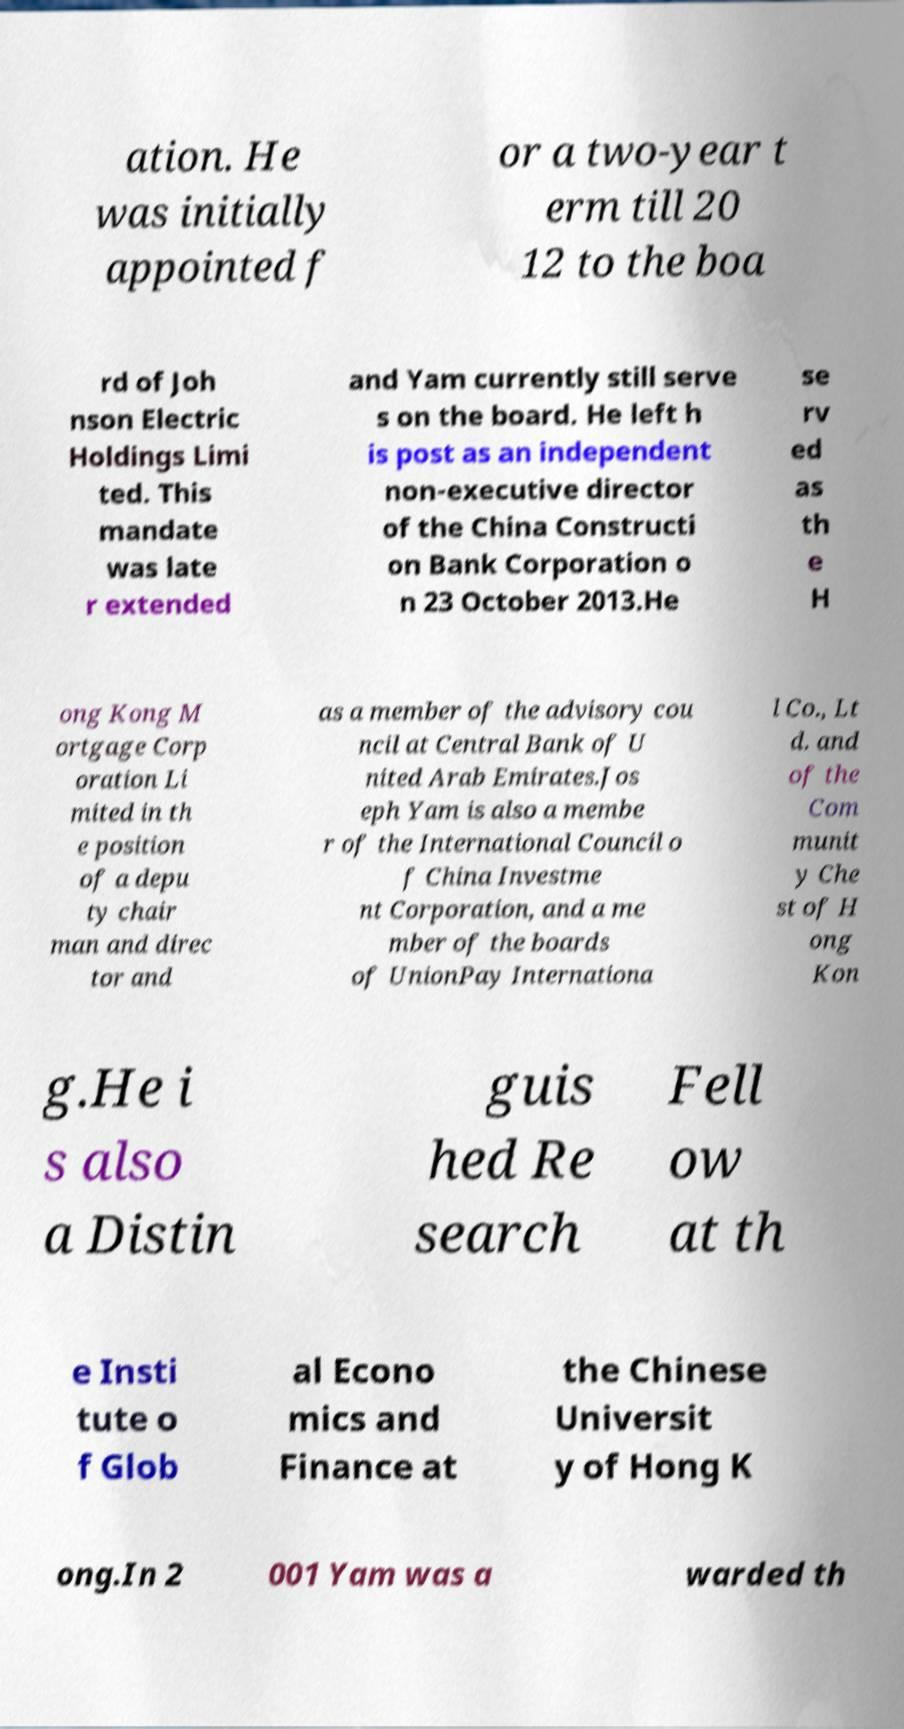Could you extract and type out the text from this image? ation. He was initially appointed f or a two-year t erm till 20 12 to the boa rd of Joh nson Electric Holdings Limi ted. This mandate was late r extended and Yam currently still serve s on the board. He left h is post as an independent non-executive director of the China Constructi on Bank Corporation o n 23 October 2013.He se rv ed as th e H ong Kong M ortgage Corp oration Li mited in th e position of a depu ty chair man and direc tor and as a member of the advisory cou ncil at Central Bank of U nited Arab Emirates.Jos eph Yam is also a membe r of the International Council o f China Investme nt Corporation, and a me mber of the boards of UnionPay Internationa l Co., Lt d. and of the Com munit y Che st of H ong Kon g.He i s also a Distin guis hed Re search Fell ow at th e Insti tute o f Glob al Econo mics and Finance at the Chinese Universit y of Hong K ong.In 2 001 Yam was a warded th 